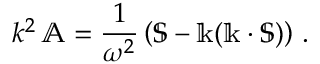<formula> <loc_0><loc_0><loc_500><loc_500>k ^ { 2 } \, \mathbb { A } = { \frac { 1 } { \omega ^ { 2 } } } \left ( \mathbb { S } - \mathbb { k } ( \mathbb { k } \cdot \mathbb { S } ) \right ) \, .</formula> 